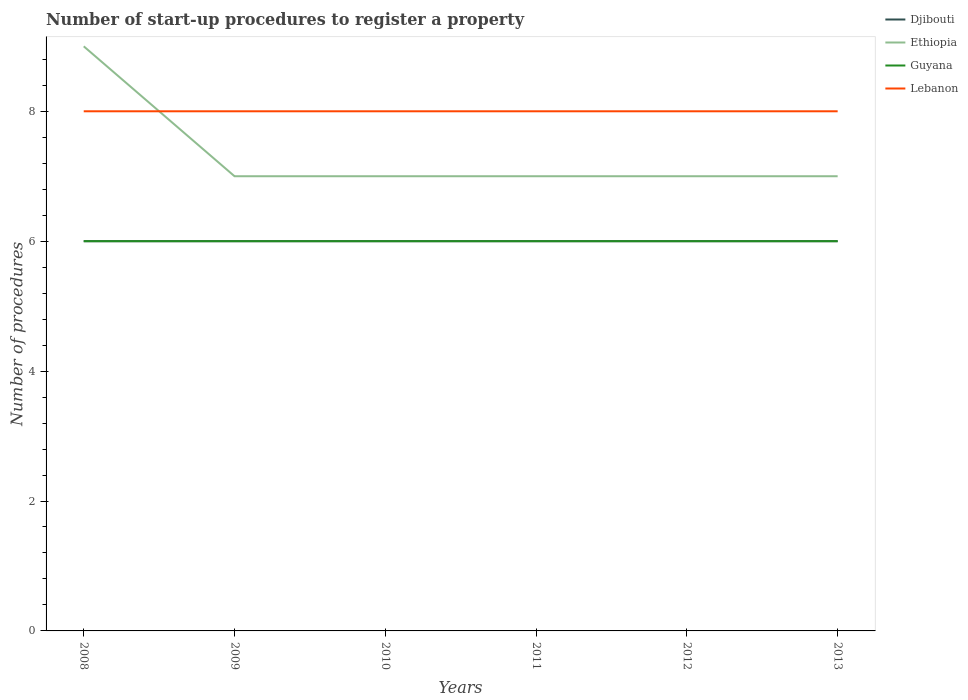How many different coloured lines are there?
Your answer should be very brief. 4. Does the line corresponding to Lebanon intersect with the line corresponding to Guyana?
Provide a succinct answer. No. Across all years, what is the maximum number of procedures required to register a property in Lebanon?
Ensure brevity in your answer.  8. In which year was the number of procedures required to register a property in Ethiopia maximum?
Keep it short and to the point. 2009. What is the total number of procedures required to register a property in Guyana in the graph?
Provide a short and direct response. 0. What is the difference between the highest and the lowest number of procedures required to register a property in Djibouti?
Provide a short and direct response. 0. Is the number of procedures required to register a property in Lebanon strictly greater than the number of procedures required to register a property in Guyana over the years?
Give a very brief answer. No. How many lines are there?
Provide a short and direct response. 4. How many years are there in the graph?
Your answer should be compact. 6. What is the difference between two consecutive major ticks on the Y-axis?
Make the answer very short. 2. Does the graph contain any zero values?
Your answer should be compact. No. How many legend labels are there?
Provide a succinct answer. 4. What is the title of the graph?
Keep it short and to the point. Number of start-up procedures to register a property. Does "North America" appear as one of the legend labels in the graph?
Offer a terse response. No. What is the label or title of the Y-axis?
Offer a very short reply. Number of procedures. What is the Number of procedures in Djibouti in 2008?
Your response must be concise. 6. What is the Number of procedures of Ethiopia in 2008?
Keep it short and to the point. 9. What is the Number of procedures of Guyana in 2009?
Your answer should be very brief. 6. What is the Number of procedures of Djibouti in 2010?
Give a very brief answer. 6. What is the Number of procedures in Ethiopia in 2010?
Offer a very short reply. 7. What is the Number of procedures of Lebanon in 2010?
Your answer should be very brief. 8. What is the Number of procedures of Guyana in 2011?
Offer a terse response. 6. What is the Number of procedures of Djibouti in 2012?
Offer a very short reply. 6. What is the Number of procedures of Guyana in 2012?
Give a very brief answer. 6. What is the Number of procedures of Lebanon in 2012?
Provide a succinct answer. 8. What is the Number of procedures of Ethiopia in 2013?
Make the answer very short. 7. What is the Number of procedures in Guyana in 2013?
Make the answer very short. 6. Across all years, what is the maximum Number of procedures of Djibouti?
Give a very brief answer. 6. Across all years, what is the maximum Number of procedures of Ethiopia?
Your answer should be compact. 9. Across all years, what is the maximum Number of procedures in Guyana?
Keep it short and to the point. 6. Across all years, what is the maximum Number of procedures in Lebanon?
Your answer should be very brief. 8. Across all years, what is the minimum Number of procedures in Lebanon?
Offer a very short reply. 8. What is the difference between the Number of procedures of Guyana in 2008 and that in 2009?
Give a very brief answer. 0. What is the difference between the Number of procedures of Lebanon in 2008 and that in 2009?
Offer a very short reply. 0. What is the difference between the Number of procedures in Guyana in 2008 and that in 2010?
Provide a short and direct response. 0. What is the difference between the Number of procedures of Lebanon in 2008 and that in 2010?
Your answer should be very brief. 0. What is the difference between the Number of procedures of Ethiopia in 2008 and that in 2011?
Your response must be concise. 2. What is the difference between the Number of procedures in Guyana in 2008 and that in 2011?
Your response must be concise. 0. What is the difference between the Number of procedures in Ethiopia in 2008 and that in 2012?
Your answer should be very brief. 2. What is the difference between the Number of procedures of Ethiopia in 2008 and that in 2013?
Offer a terse response. 2. What is the difference between the Number of procedures in Ethiopia in 2009 and that in 2010?
Make the answer very short. 0. What is the difference between the Number of procedures in Djibouti in 2009 and that in 2011?
Provide a succinct answer. 0. What is the difference between the Number of procedures of Djibouti in 2009 and that in 2012?
Make the answer very short. 0. What is the difference between the Number of procedures of Ethiopia in 2009 and that in 2012?
Your answer should be compact. 0. What is the difference between the Number of procedures of Lebanon in 2009 and that in 2012?
Keep it short and to the point. 0. What is the difference between the Number of procedures of Djibouti in 2009 and that in 2013?
Your response must be concise. 0. What is the difference between the Number of procedures in Guyana in 2009 and that in 2013?
Offer a terse response. 0. What is the difference between the Number of procedures of Guyana in 2010 and that in 2011?
Provide a succinct answer. 0. What is the difference between the Number of procedures of Djibouti in 2010 and that in 2012?
Make the answer very short. 0. What is the difference between the Number of procedures of Djibouti in 2010 and that in 2013?
Your response must be concise. 0. What is the difference between the Number of procedures in Ethiopia in 2010 and that in 2013?
Offer a terse response. 0. What is the difference between the Number of procedures of Guyana in 2010 and that in 2013?
Offer a very short reply. 0. What is the difference between the Number of procedures in Djibouti in 2011 and that in 2013?
Give a very brief answer. 0. What is the difference between the Number of procedures of Djibouti in 2012 and that in 2013?
Offer a very short reply. 0. What is the difference between the Number of procedures of Guyana in 2012 and that in 2013?
Your answer should be compact. 0. What is the difference between the Number of procedures in Djibouti in 2008 and the Number of procedures in Ethiopia in 2009?
Provide a short and direct response. -1. What is the difference between the Number of procedures of Djibouti in 2008 and the Number of procedures of Guyana in 2009?
Offer a terse response. 0. What is the difference between the Number of procedures in Guyana in 2008 and the Number of procedures in Lebanon in 2009?
Give a very brief answer. -2. What is the difference between the Number of procedures of Ethiopia in 2008 and the Number of procedures of Lebanon in 2010?
Give a very brief answer. 1. What is the difference between the Number of procedures of Djibouti in 2008 and the Number of procedures of Guyana in 2011?
Offer a very short reply. 0. What is the difference between the Number of procedures of Ethiopia in 2008 and the Number of procedures of Lebanon in 2011?
Make the answer very short. 1. What is the difference between the Number of procedures in Guyana in 2008 and the Number of procedures in Lebanon in 2011?
Provide a short and direct response. -2. What is the difference between the Number of procedures in Djibouti in 2008 and the Number of procedures in Ethiopia in 2012?
Give a very brief answer. -1. What is the difference between the Number of procedures in Djibouti in 2008 and the Number of procedures in Guyana in 2012?
Your answer should be very brief. 0. What is the difference between the Number of procedures in Ethiopia in 2008 and the Number of procedures in Guyana in 2012?
Keep it short and to the point. 3. What is the difference between the Number of procedures of Guyana in 2008 and the Number of procedures of Lebanon in 2012?
Offer a very short reply. -2. What is the difference between the Number of procedures in Djibouti in 2008 and the Number of procedures in Ethiopia in 2013?
Keep it short and to the point. -1. What is the difference between the Number of procedures of Djibouti in 2008 and the Number of procedures of Guyana in 2013?
Provide a succinct answer. 0. What is the difference between the Number of procedures of Djibouti in 2009 and the Number of procedures of Guyana in 2010?
Your answer should be very brief. 0. What is the difference between the Number of procedures of Djibouti in 2009 and the Number of procedures of Lebanon in 2010?
Provide a succinct answer. -2. What is the difference between the Number of procedures of Ethiopia in 2009 and the Number of procedures of Guyana in 2010?
Provide a succinct answer. 1. What is the difference between the Number of procedures in Ethiopia in 2009 and the Number of procedures in Lebanon in 2010?
Your answer should be very brief. -1. What is the difference between the Number of procedures in Djibouti in 2009 and the Number of procedures in Ethiopia in 2011?
Your answer should be compact. -1. What is the difference between the Number of procedures in Djibouti in 2009 and the Number of procedures in Guyana in 2011?
Your answer should be compact. 0. What is the difference between the Number of procedures of Djibouti in 2009 and the Number of procedures of Lebanon in 2011?
Your response must be concise. -2. What is the difference between the Number of procedures in Djibouti in 2009 and the Number of procedures in Lebanon in 2012?
Ensure brevity in your answer.  -2. What is the difference between the Number of procedures of Ethiopia in 2009 and the Number of procedures of Lebanon in 2012?
Offer a terse response. -1. What is the difference between the Number of procedures in Guyana in 2009 and the Number of procedures in Lebanon in 2012?
Provide a succinct answer. -2. What is the difference between the Number of procedures in Djibouti in 2009 and the Number of procedures in Ethiopia in 2013?
Offer a very short reply. -1. What is the difference between the Number of procedures in Djibouti in 2009 and the Number of procedures in Guyana in 2013?
Give a very brief answer. 0. What is the difference between the Number of procedures in Guyana in 2009 and the Number of procedures in Lebanon in 2013?
Keep it short and to the point. -2. What is the difference between the Number of procedures of Djibouti in 2010 and the Number of procedures of Guyana in 2011?
Your answer should be compact. 0. What is the difference between the Number of procedures in Guyana in 2010 and the Number of procedures in Lebanon in 2011?
Offer a very short reply. -2. What is the difference between the Number of procedures of Djibouti in 2010 and the Number of procedures of Guyana in 2012?
Give a very brief answer. 0. What is the difference between the Number of procedures of Djibouti in 2010 and the Number of procedures of Lebanon in 2012?
Offer a very short reply. -2. What is the difference between the Number of procedures in Ethiopia in 2010 and the Number of procedures in Guyana in 2012?
Make the answer very short. 1. What is the difference between the Number of procedures in Djibouti in 2010 and the Number of procedures in Ethiopia in 2013?
Your answer should be very brief. -1. What is the difference between the Number of procedures of Djibouti in 2010 and the Number of procedures of Guyana in 2013?
Give a very brief answer. 0. What is the difference between the Number of procedures in Djibouti in 2011 and the Number of procedures in Lebanon in 2012?
Your answer should be compact. -2. What is the difference between the Number of procedures in Guyana in 2011 and the Number of procedures in Lebanon in 2012?
Your answer should be very brief. -2. What is the difference between the Number of procedures of Ethiopia in 2011 and the Number of procedures of Lebanon in 2013?
Your answer should be very brief. -1. What is the difference between the Number of procedures in Guyana in 2011 and the Number of procedures in Lebanon in 2013?
Ensure brevity in your answer.  -2. What is the difference between the Number of procedures of Djibouti in 2012 and the Number of procedures of Ethiopia in 2013?
Your response must be concise. -1. What is the difference between the Number of procedures in Djibouti in 2012 and the Number of procedures in Guyana in 2013?
Provide a succinct answer. 0. What is the difference between the Number of procedures of Ethiopia in 2012 and the Number of procedures of Lebanon in 2013?
Give a very brief answer. -1. What is the difference between the Number of procedures of Guyana in 2012 and the Number of procedures of Lebanon in 2013?
Provide a succinct answer. -2. What is the average Number of procedures of Djibouti per year?
Your answer should be very brief. 6. What is the average Number of procedures in Ethiopia per year?
Your answer should be compact. 7.33. What is the average Number of procedures in Guyana per year?
Offer a very short reply. 6. What is the average Number of procedures of Lebanon per year?
Keep it short and to the point. 8. In the year 2008, what is the difference between the Number of procedures in Djibouti and Number of procedures in Ethiopia?
Provide a short and direct response. -3. In the year 2008, what is the difference between the Number of procedures in Ethiopia and Number of procedures in Lebanon?
Make the answer very short. 1. In the year 2008, what is the difference between the Number of procedures of Guyana and Number of procedures of Lebanon?
Offer a terse response. -2. In the year 2009, what is the difference between the Number of procedures in Djibouti and Number of procedures in Guyana?
Offer a terse response. 0. In the year 2009, what is the difference between the Number of procedures in Djibouti and Number of procedures in Lebanon?
Your answer should be compact. -2. In the year 2009, what is the difference between the Number of procedures of Guyana and Number of procedures of Lebanon?
Ensure brevity in your answer.  -2. In the year 2010, what is the difference between the Number of procedures in Djibouti and Number of procedures in Ethiopia?
Offer a terse response. -1. In the year 2010, what is the difference between the Number of procedures in Djibouti and Number of procedures in Guyana?
Your response must be concise. 0. In the year 2010, what is the difference between the Number of procedures in Djibouti and Number of procedures in Lebanon?
Give a very brief answer. -2. In the year 2010, what is the difference between the Number of procedures of Ethiopia and Number of procedures of Lebanon?
Ensure brevity in your answer.  -1. In the year 2011, what is the difference between the Number of procedures of Djibouti and Number of procedures of Lebanon?
Keep it short and to the point. -2. In the year 2012, what is the difference between the Number of procedures of Djibouti and Number of procedures of Ethiopia?
Your answer should be compact. -1. In the year 2012, what is the difference between the Number of procedures of Djibouti and Number of procedures of Lebanon?
Make the answer very short. -2. In the year 2013, what is the difference between the Number of procedures in Djibouti and Number of procedures in Ethiopia?
Ensure brevity in your answer.  -1. In the year 2013, what is the difference between the Number of procedures of Djibouti and Number of procedures of Lebanon?
Your response must be concise. -2. In the year 2013, what is the difference between the Number of procedures in Ethiopia and Number of procedures in Guyana?
Make the answer very short. 1. In the year 2013, what is the difference between the Number of procedures in Ethiopia and Number of procedures in Lebanon?
Offer a very short reply. -1. What is the ratio of the Number of procedures of Djibouti in 2008 to that in 2009?
Your answer should be very brief. 1. What is the ratio of the Number of procedures in Guyana in 2008 to that in 2009?
Make the answer very short. 1. What is the ratio of the Number of procedures of Djibouti in 2008 to that in 2010?
Provide a succinct answer. 1. What is the ratio of the Number of procedures of Ethiopia in 2008 to that in 2011?
Your response must be concise. 1.29. What is the ratio of the Number of procedures in Lebanon in 2008 to that in 2011?
Offer a terse response. 1. What is the ratio of the Number of procedures of Ethiopia in 2008 to that in 2012?
Make the answer very short. 1.29. What is the ratio of the Number of procedures of Guyana in 2008 to that in 2012?
Your answer should be very brief. 1. What is the ratio of the Number of procedures in Lebanon in 2008 to that in 2012?
Keep it short and to the point. 1. What is the ratio of the Number of procedures in Guyana in 2008 to that in 2013?
Your answer should be compact. 1. What is the ratio of the Number of procedures of Lebanon in 2008 to that in 2013?
Provide a short and direct response. 1. What is the ratio of the Number of procedures in Ethiopia in 2009 to that in 2010?
Ensure brevity in your answer.  1. What is the ratio of the Number of procedures of Lebanon in 2009 to that in 2010?
Your answer should be very brief. 1. What is the ratio of the Number of procedures of Djibouti in 2009 to that in 2011?
Your answer should be very brief. 1. What is the ratio of the Number of procedures in Ethiopia in 2009 to that in 2011?
Offer a terse response. 1. What is the ratio of the Number of procedures in Djibouti in 2009 to that in 2012?
Make the answer very short. 1. What is the ratio of the Number of procedures in Guyana in 2009 to that in 2012?
Offer a very short reply. 1. What is the ratio of the Number of procedures of Lebanon in 2009 to that in 2012?
Offer a very short reply. 1. What is the ratio of the Number of procedures of Guyana in 2009 to that in 2013?
Keep it short and to the point. 1. What is the ratio of the Number of procedures of Lebanon in 2009 to that in 2013?
Provide a short and direct response. 1. What is the ratio of the Number of procedures of Ethiopia in 2010 to that in 2011?
Offer a very short reply. 1. What is the ratio of the Number of procedures of Guyana in 2010 to that in 2011?
Your response must be concise. 1. What is the ratio of the Number of procedures in Lebanon in 2010 to that in 2011?
Give a very brief answer. 1. What is the ratio of the Number of procedures of Djibouti in 2010 to that in 2012?
Keep it short and to the point. 1. What is the ratio of the Number of procedures in Ethiopia in 2010 to that in 2012?
Provide a short and direct response. 1. What is the ratio of the Number of procedures in Lebanon in 2010 to that in 2012?
Provide a succinct answer. 1. What is the ratio of the Number of procedures of Ethiopia in 2010 to that in 2013?
Make the answer very short. 1. What is the ratio of the Number of procedures in Lebanon in 2010 to that in 2013?
Provide a succinct answer. 1. What is the ratio of the Number of procedures in Djibouti in 2011 to that in 2012?
Provide a short and direct response. 1. What is the ratio of the Number of procedures in Djibouti in 2011 to that in 2013?
Provide a short and direct response. 1. What is the ratio of the Number of procedures in Ethiopia in 2011 to that in 2013?
Offer a very short reply. 1. What is the ratio of the Number of procedures in Lebanon in 2011 to that in 2013?
Make the answer very short. 1. What is the ratio of the Number of procedures of Djibouti in 2012 to that in 2013?
Make the answer very short. 1. What is the ratio of the Number of procedures in Lebanon in 2012 to that in 2013?
Offer a terse response. 1. What is the difference between the highest and the second highest Number of procedures in Djibouti?
Give a very brief answer. 0. What is the difference between the highest and the second highest Number of procedures of Ethiopia?
Give a very brief answer. 2. What is the difference between the highest and the second highest Number of procedures of Lebanon?
Your answer should be very brief. 0. What is the difference between the highest and the lowest Number of procedures in Djibouti?
Provide a short and direct response. 0. 